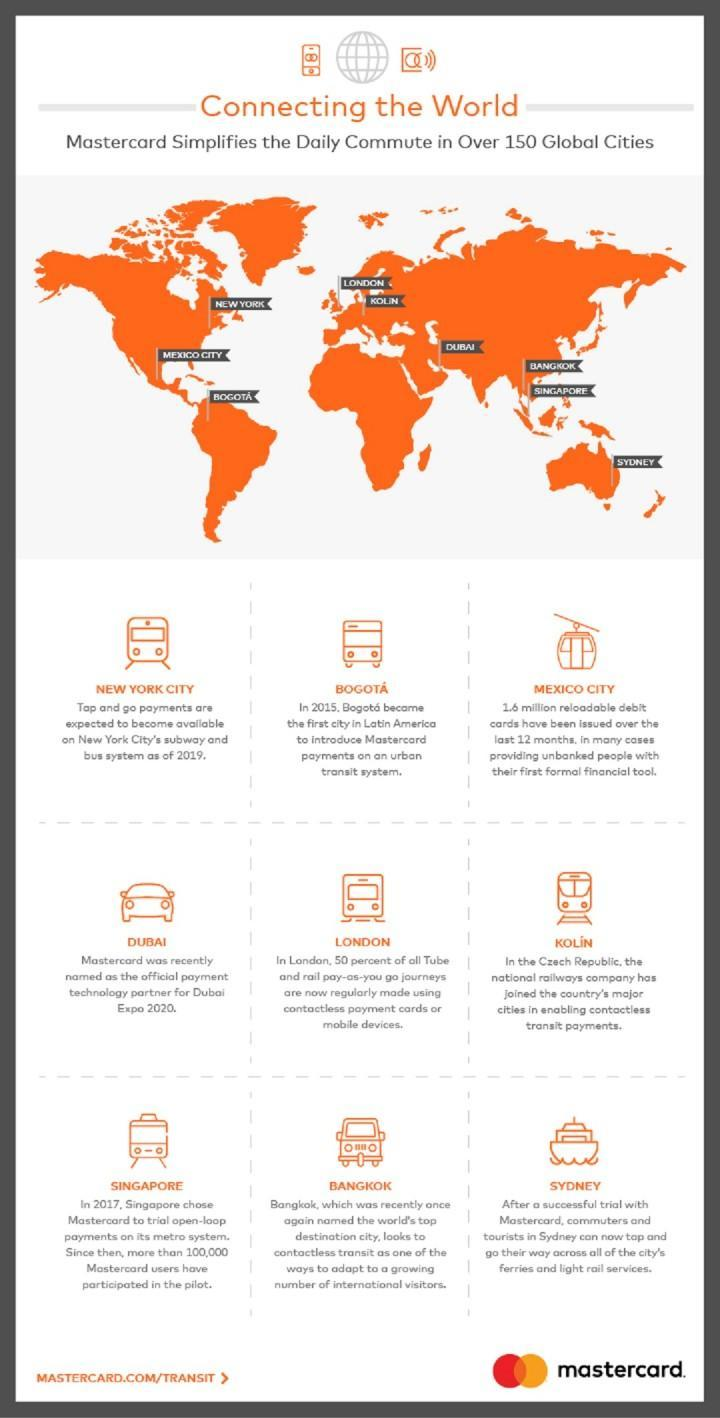Which city provides the facility to use Master cards in every ferries and light rail services?
Answer the question with a short phrase. Sydney Which is the city shown in the map which is an island in the right most corner? Sydney Which is the major town in Czech Republic that provides contact-less transit payments? Kolin Which is the earliest city that has started using MasterCard in transit system? Bogota Which city was named as the world's peak destination city? Bangkok 